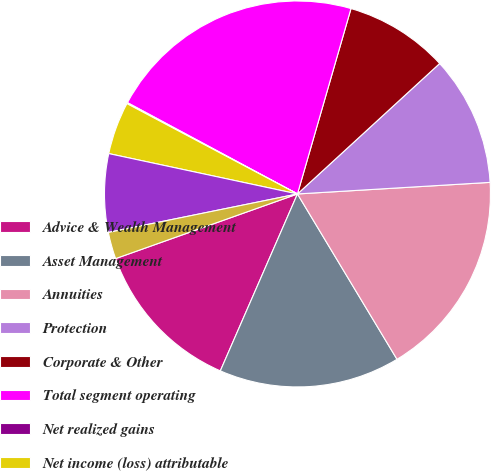<chart> <loc_0><loc_0><loc_500><loc_500><pie_chart><fcel>Advice & Wealth Management<fcel>Asset Management<fcel>Annuities<fcel>Protection<fcel>Corporate & Other<fcel>Total segment operating<fcel>Net realized gains<fcel>Net income (loss) attributable<fcel>Market impact on variable<fcel>Integration and restructuring<nl><fcel>13.02%<fcel>15.17%<fcel>17.33%<fcel>10.86%<fcel>8.71%<fcel>21.63%<fcel>0.09%<fcel>4.4%<fcel>6.55%<fcel>2.24%<nl></chart> 